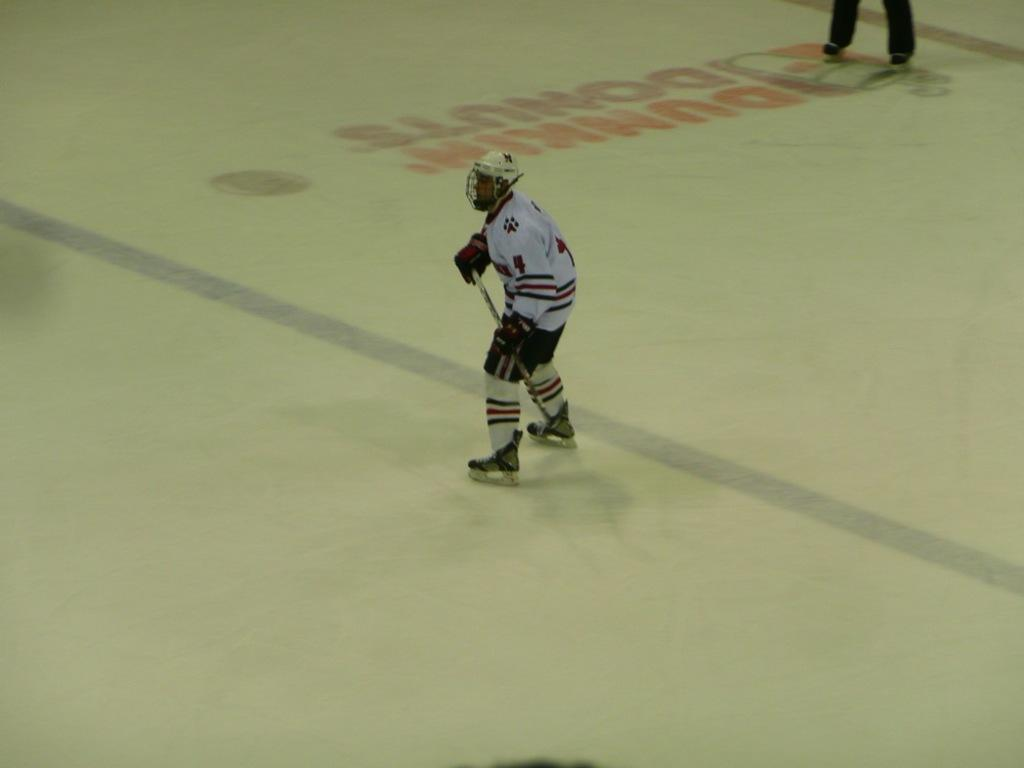<image>
Give a short and clear explanation of the subsequent image. Hockey player standing an ice rink that says Dunkin DOnuts on it. 